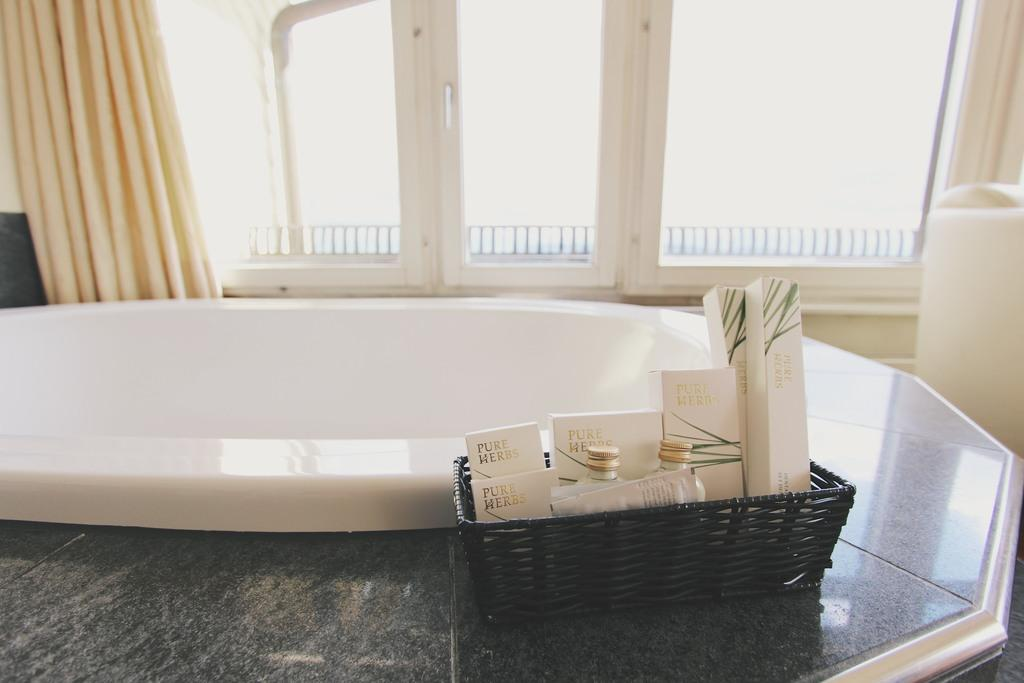What is the main object in the image? There is a bathtub in the image. What can be seen beside the bathtub? There are bottles and a basket beside the bathtub. What is visible in the background of the image? There are curtains and metal rods in the background of the image. How many women are attending the meeting in the image? There is no meeting or women present in the image. What type of rice is being served in the image? There is no rice present in the image. 